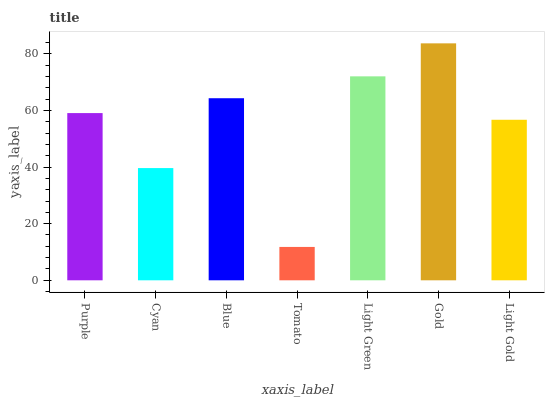Is Tomato the minimum?
Answer yes or no. Yes. Is Gold the maximum?
Answer yes or no. Yes. Is Cyan the minimum?
Answer yes or no. No. Is Cyan the maximum?
Answer yes or no. No. Is Purple greater than Cyan?
Answer yes or no. Yes. Is Cyan less than Purple?
Answer yes or no. Yes. Is Cyan greater than Purple?
Answer yes or no. No. Is Purple less than Cyan?
Answer yes or no. No. Is Purple the high median?
Answer yes or no. Yes. Is Purple the low median?
Answer yes or no. Yes. Is Cyan the high median?
Answer yes or no. No. Is Gold the low median?
Answer yes or no. No. 